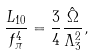Convert formula to latex. <formula><loc_0><loc_0><loc_500><loc_500>\frac { L _ { 1 0 } } { f _ { \pi } ^ { 4 } } = \frac { 3 } { 4 } \frac { { \hat { \Omega } } } { \Lambda _ { 3 } ^ { 2 } } ,</formula> 